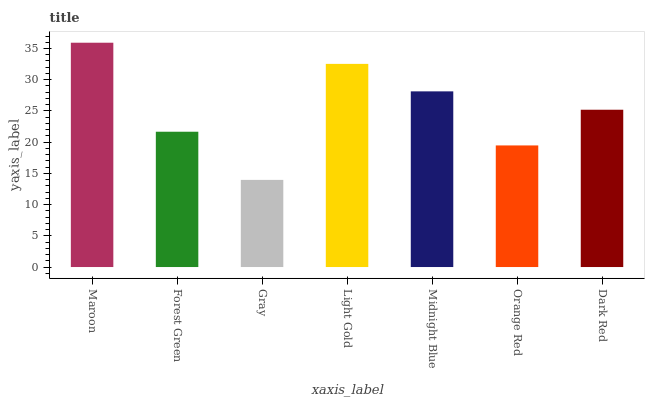Is Gray the minimum?
Answer yes or no. Yes. Is Maroon the maximum?
Answer yes or no. Yes. Is Forest Green the minimum?
Answer yes or no. No. Is Forest Green the maximum?
Answer yes or no. No. Is Maroon greater than Forest Green?
Answer yes or no. Yes. Is Forest Green less than Maroon?
Answer yes or no. Yes. Is Forest Green greater than Maroon?
Answer yes or no. No. Is Maroon less than Forest Green?
Answer yes or no. No. Is Dark Red the high median?
Answer yes or no. Yes. Is Dark Red the low median?
Answer yes or no. Yes. Is Maroon the high median?
Answer yes or no. No. Is Forest Green the low median?
Answer yes or no. No. 